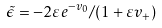<formula> <loc_0><loc_0><loc_500><loc_500>\tilde { \epsilon } = - 2 \varepsilon e ^ { - v _ { 0 } } / ( 1 + \varepsilon v _ { + } )</formula> 